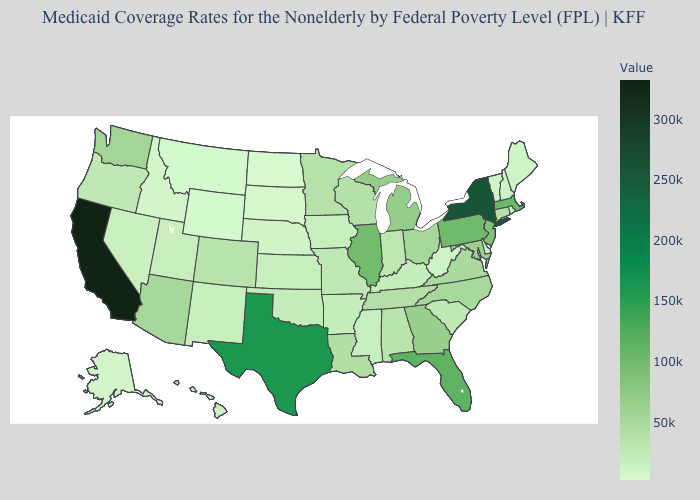Among the states that border Texas , does Oklahoma have the highest value?
Quick response, please. No. Does Kansas have a lower value than Georgia?
Short answer required. Yes. Which states have the lowest value in the West?
Keep it brief. Wyoming. Does South Carolina have the lowest value in the USA?
Answer briefly. No. Among the states that border Louisiana , does Arkansas have the highest value?
Answer briefly. No. Which states have the lowest value in the West?
Quick response, please. Wyoming. Does North Dakota have the lowest value in the MidWest?
Short answer required. Yes. 